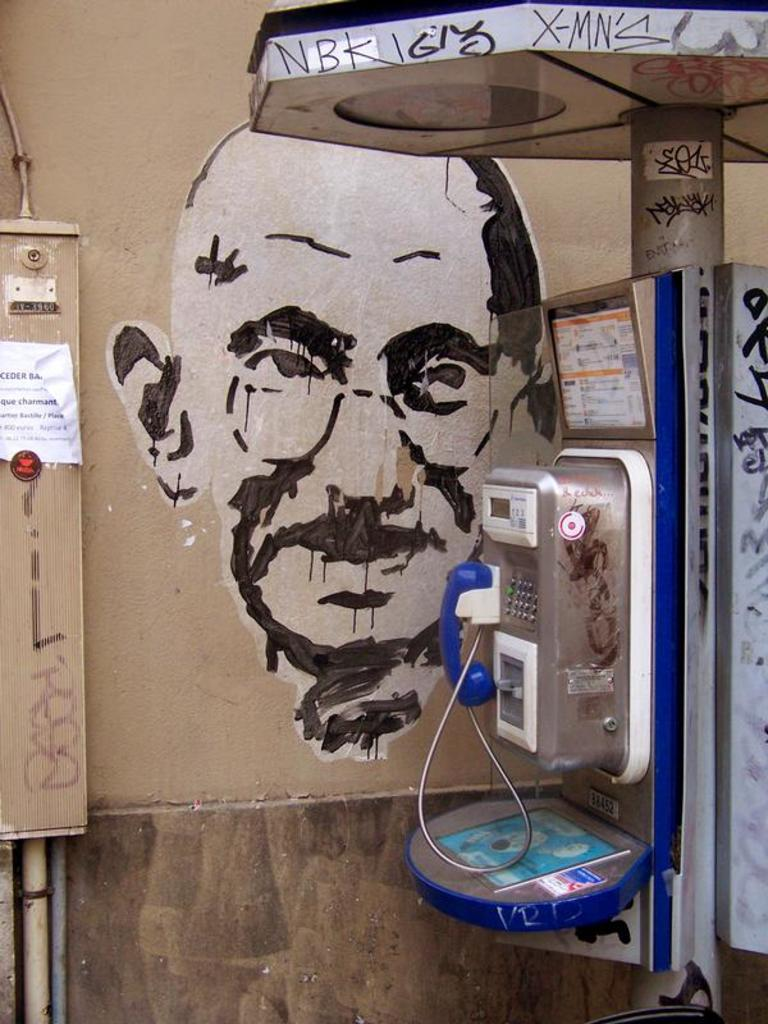What communication device is present in the image? There is a telephone in the image. What vertical structure can be seen in the image? There is a pole in the image. What type of conduit is visible in the image? There is a pipe in the image. What type of printed material is present in the image? There is a poster in the image. What type of artwork is present on the wall in the image? There is a painting on the wall in the image. Can you describe any other objects in the image? There are some unspecified objects in the image. How many cows are grazing in the image? There are no cows present in the image. What type of train is visible in the image? There is no train present in the image. 